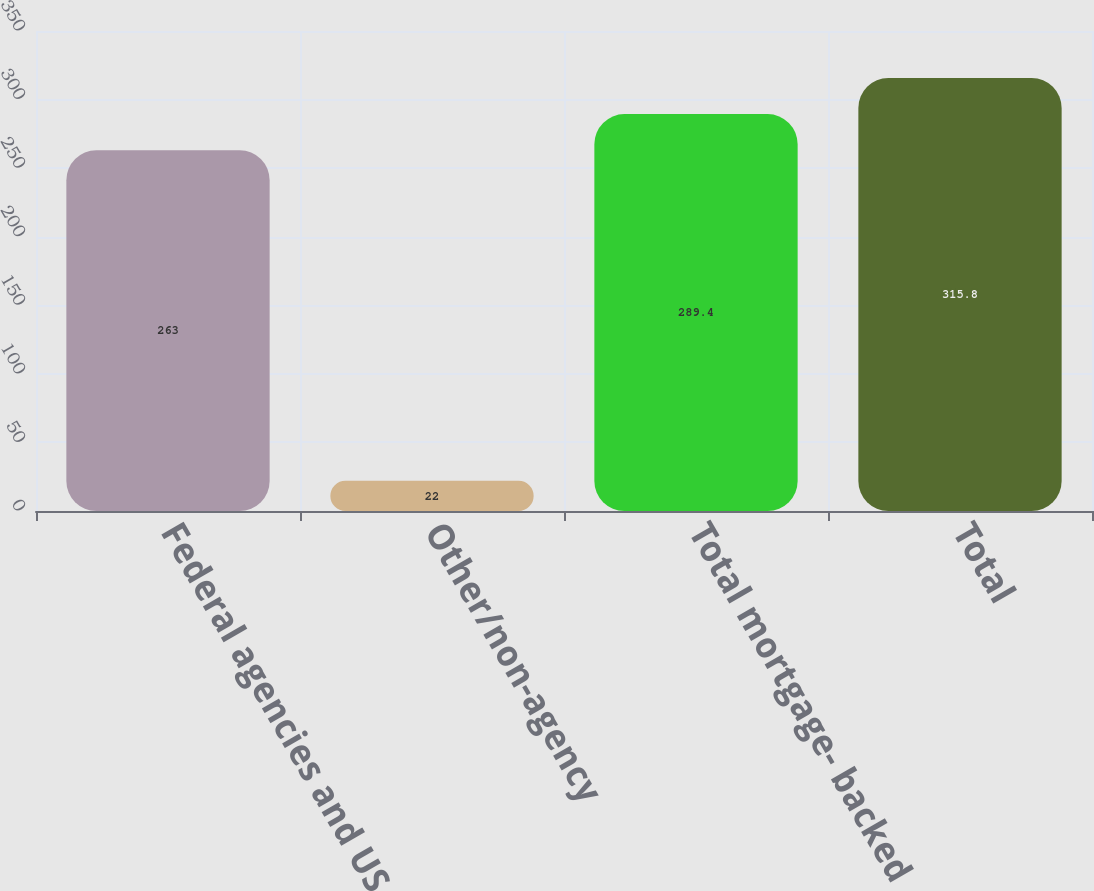<chart> <loc_0><loc_0><loc_500><loc_500><bar_chart><fcel>Federal agencies and US<fcel>Other/non-agency<fcel>Total mortgage- backed<fcel>Total<nl><fcel>263<fcel>22<fcel>289.4<fcel>315.8<nl></chart> 